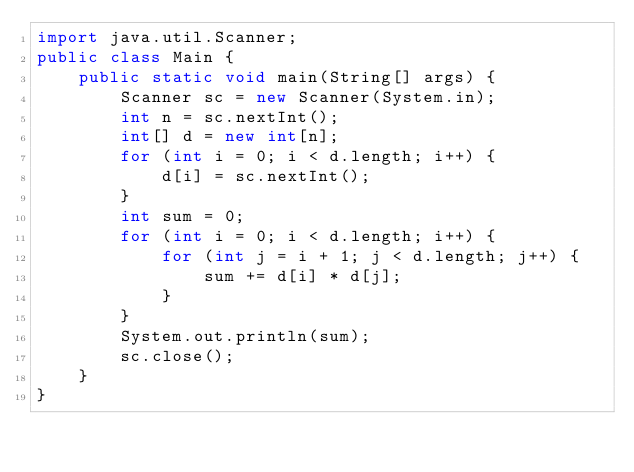Convert code to text. <code><loc_0><loc_0><loc_500><loc_500><_Java_>import java.util.Scanner;
public class Main {
    public static void main(String[] args) {
        Scanner sc = new Scanner(System.in);
        int n = sc.nextInt();
        int[] d = new int[n];
        for (int i = 0; i < d.length; i++) {
            d[i] = sc.nextInt();
        }
        int sum = 0;
        for (int i = 0; i < d.length; i++) {
            for (int j = i + 1; j < d.length; j++) {
                sum += d[i] * d[j];
            }
        }
        System.out.println(sum);
        sc.close();
    }
}</code> 